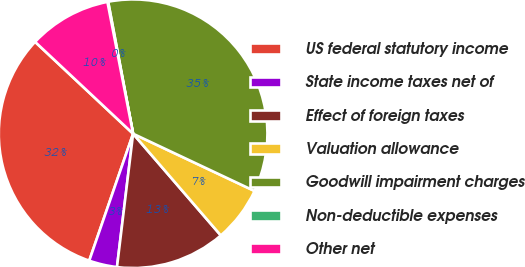Convert chart to OTSL. <chart><loc_0><loc_0><loc_500><loc_500><pie_chart><fcel>US federal statutory income<fcel>State income taxes net of<fcel>Effect of foreign taxes<fcel>Valuation allowance<fcel>Goodwill impairment charges<fcel>Non-deductible expenses<fcel>Other net<nl><fcel>31.69%<fcel>3.38%<fcel>13.24%<fcel>6.66%<fcel>34.98%<fcel>0.09%<fcel>9.95%<nl></chart> 